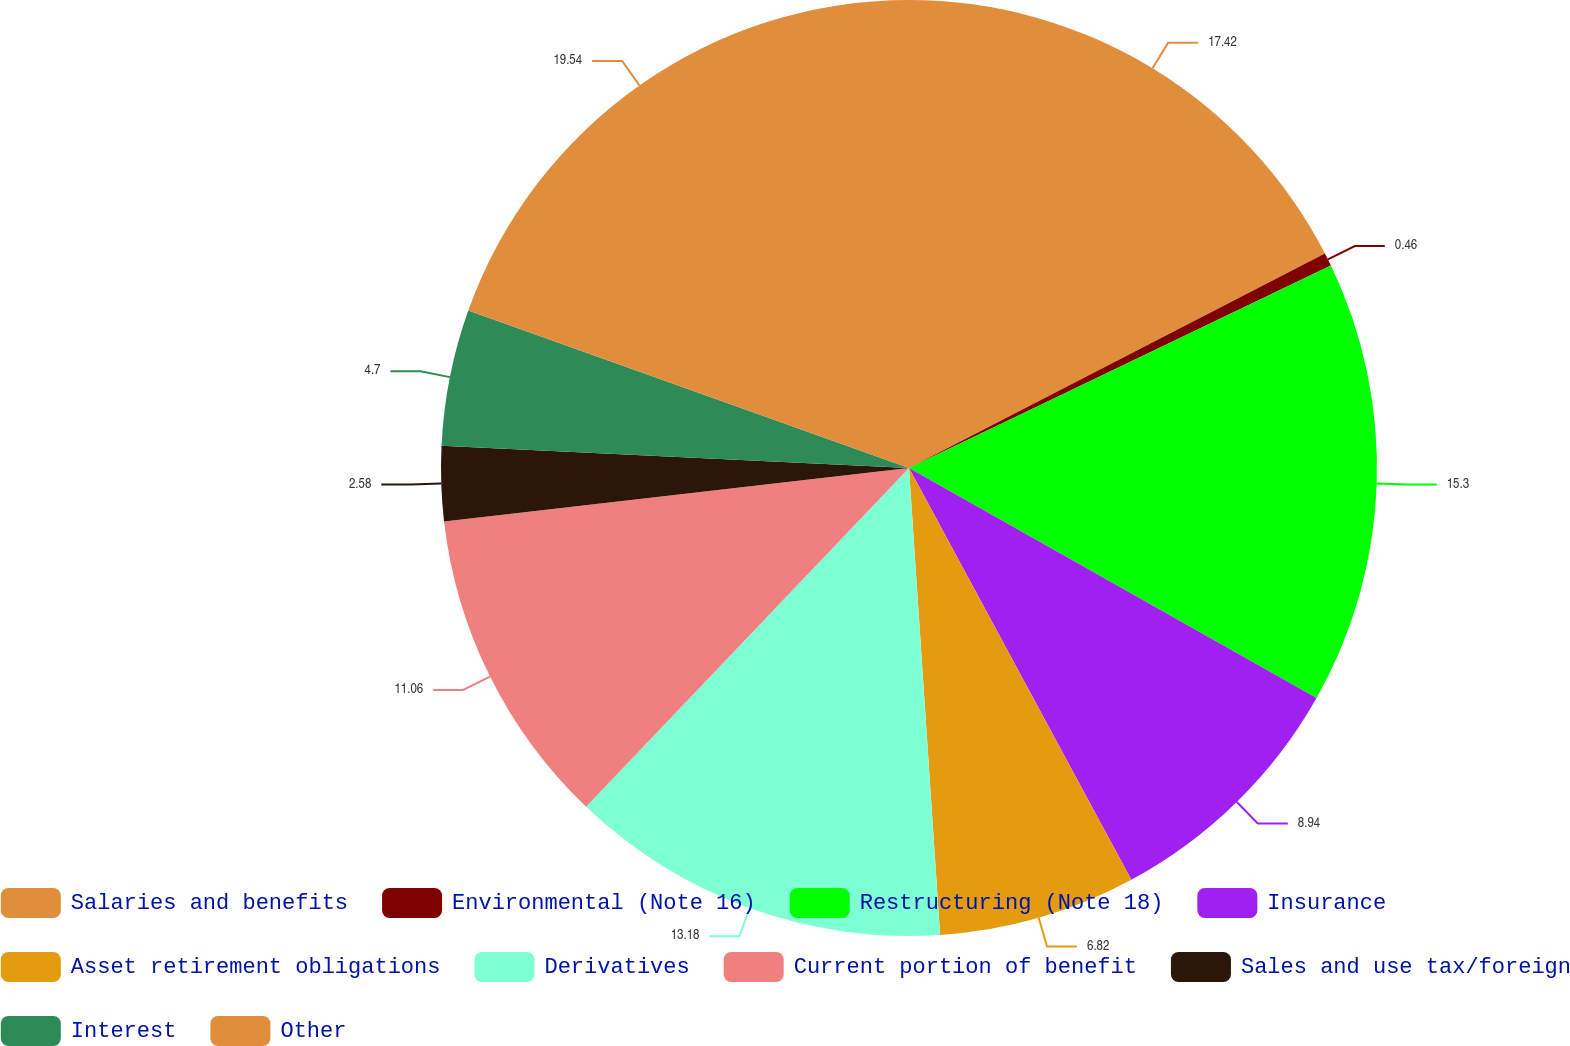<chart> <loc_0><loc_0><loc_500><loc_500><pie_chart><fcel>Salaries and benefits<fcel>Environmental (Note 16)<fcel>Restructuring (Note 18)<fcel>Insurance<fcel>Asset retirement obligations<fcel>Derivatives<fcel>Current portion of benefit<fcel>Sales and use tax/foreign<fcel>Interest<fcel>Other<nl><fcel>17.42%<fcel>0.46%<fcel>15.3%<fcel>8.94%<fcel>6.82%<fcel>13.18%<fcel>11.06%<fcel>2.58%<fcel>4.7%<fcel>19.54%<nl></chart> 